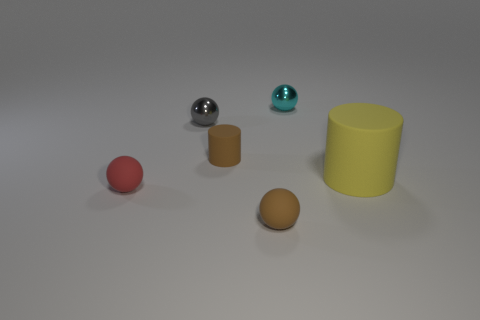Are there any other things that have the same size as the yellow rubber object?
Offer a very short reply. No. What is the size of the thing that is the same color as the tiny cylinder?
Your answer should be compact. Small. There is a tiny brown thing that is to the left of the small matte ball that is right of the small gray metal object behind the big cylinder; what is its shape?
Ensure brevity in your answer.  Cylinder. What color is the small ball that is behind the yellow rubber thing and to the left of the cyan sphere?
Provide a succinct answer. Gray. There is a brown matte object that is behind the large rubber thing; what shape is it?
Your answer should be compact. Cylinder. The yellow object that is made of the same material as the brown cylinder is what shape?
Keep it short and to the point. Cylinder. What number of rubber things are either tiny green cylinders or small red balls?
Your response must be concise. 1. There is a tiny brown object that is behind the brown object that is in front of the large yellow cylinder; what number of brown matte things are in front of it?
Keep it short and to the point. 1. Does the metal sphere that is on the right side of the gray sphere have the same size as the cylinder that is behind the yellow rubber cylinder?
Provide a short and direct response. Yes. There is another thing that is the same shape as the yellow matte object; what is it made of?
Offer a terse response. Rubber. 